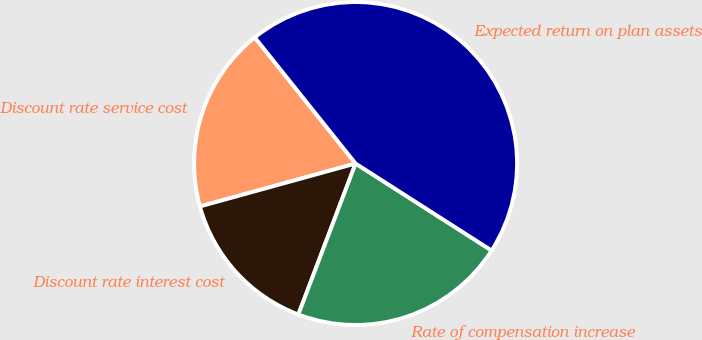Convert chart. <chart><loc_0><loc_0><loc_500><loc_500><pie_chart><fcel>Discount rate service cost<fcel>Discount rate interest cost<fcel>Rate of compensation increase<fcel>Expected return on plan assets<nl><fcel>18.55%<fcel>14.95%<fcel>21.71%<fcel>44.79%<nl></chart> 